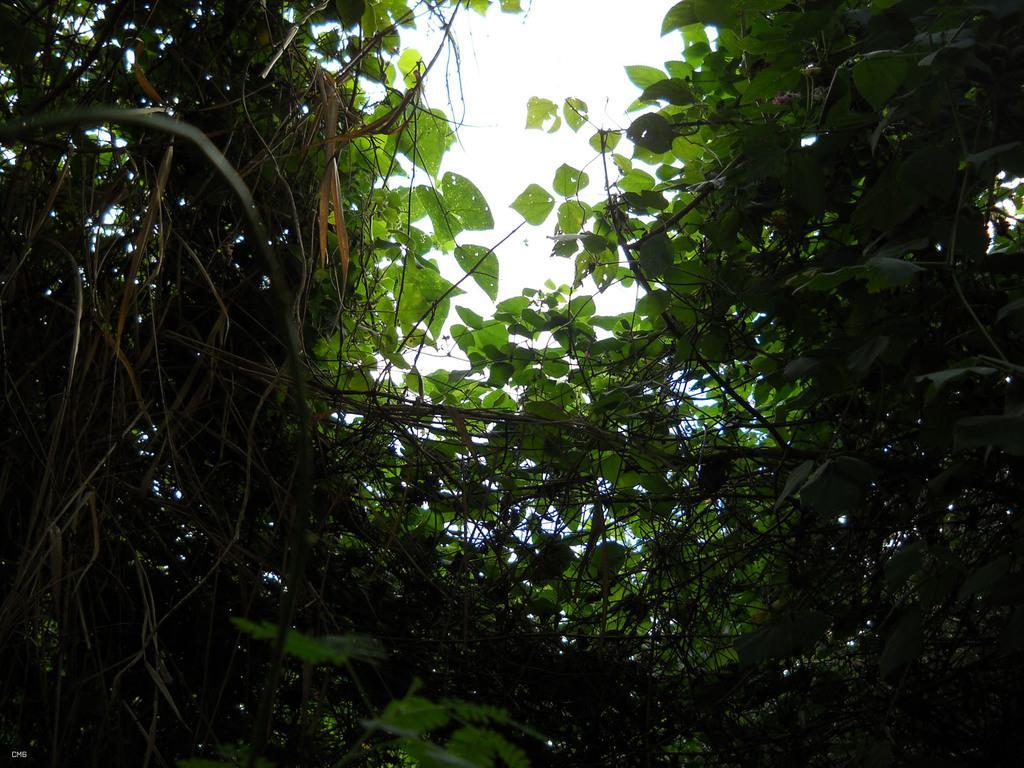Can you describe this image briefly? In this image there are few creepers having leaves. Behind there is sky. 